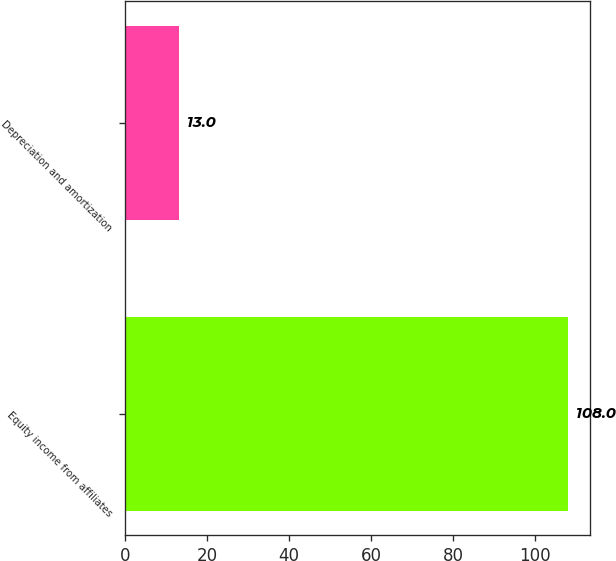Convert chart. <chart><loc_0><loc_0><loc_500><loc_500><bar_chart><fcel>Equity income from affiliates<fcel>Depreciation and amortization<nl><fcel>108<fcel>13<nl></chart> 